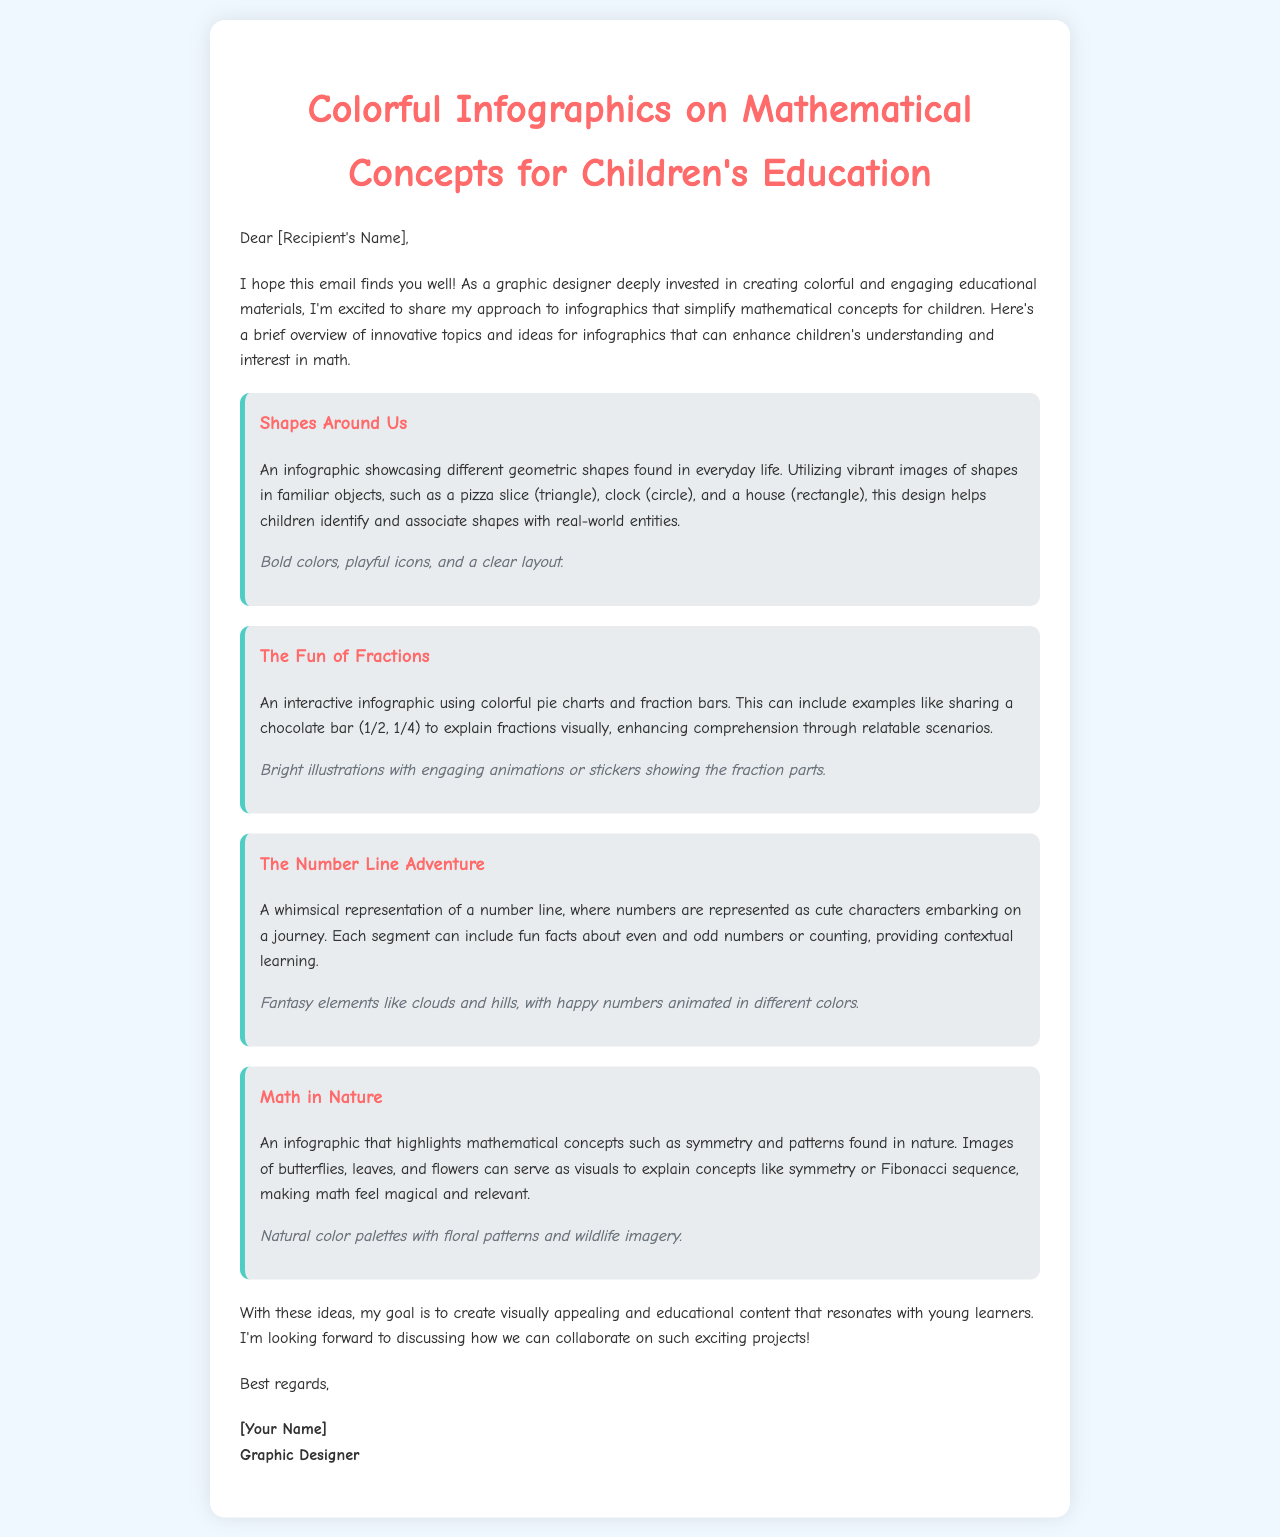What is the title of the document? The title of the document is indicated at the top of the email.
Answer: Colorful Infographics on Mathematical Concepts for Children's Education Who is addressed in the greeting? The greeting mentions a placeholder for the recipient's name.
Answer: [Recipient's Name] What is one topic covered in the infographics? Each infographic section includes a main topic; one example is listed.
Answer: Shapes Around Us How many infographics are detailed in the document? The document outlines four distinct infographics related to math concepts.
Answer: Four What is the purpose of the document? The introduction of the email summarizes the main intention behind the creation of the document.
Answer: To share an approach to infographics that simplify mathematical concepts for children What visual element is used in "The Fun of Fractions"? The infographic on fractions specifically mentions a type of visual representation.
Answer: Colorful pie charts What is the design style mentioned in the document? The style of the document emphasizes the types of elements used in illustrations.
Answer: Vibrant images and bold colors What does the author express interest in at the end? The conclusion highlights what the author is looking forward to discussing.
Answer: Collaboration on such exciting projects Who is the author of the document? The signature at the end provides the author's name placeholder.
Answer: [Your Name] 